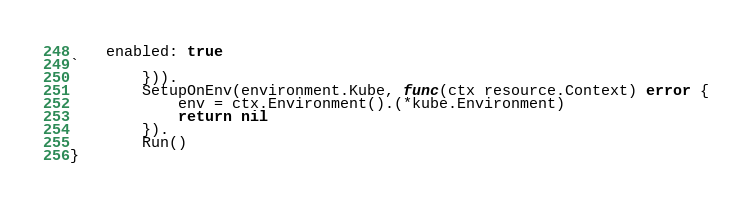<code> <loc_0><loc_0><loc_500><loc_500><_Go_>    enabled: true
`
		})).
		SetupOnEnv(environment.Kube, func(ctx resource.Context) error {
			env = ctx.Environment().(*kube.Environment)
			return nil
		}).
		Run()
}
</code> 